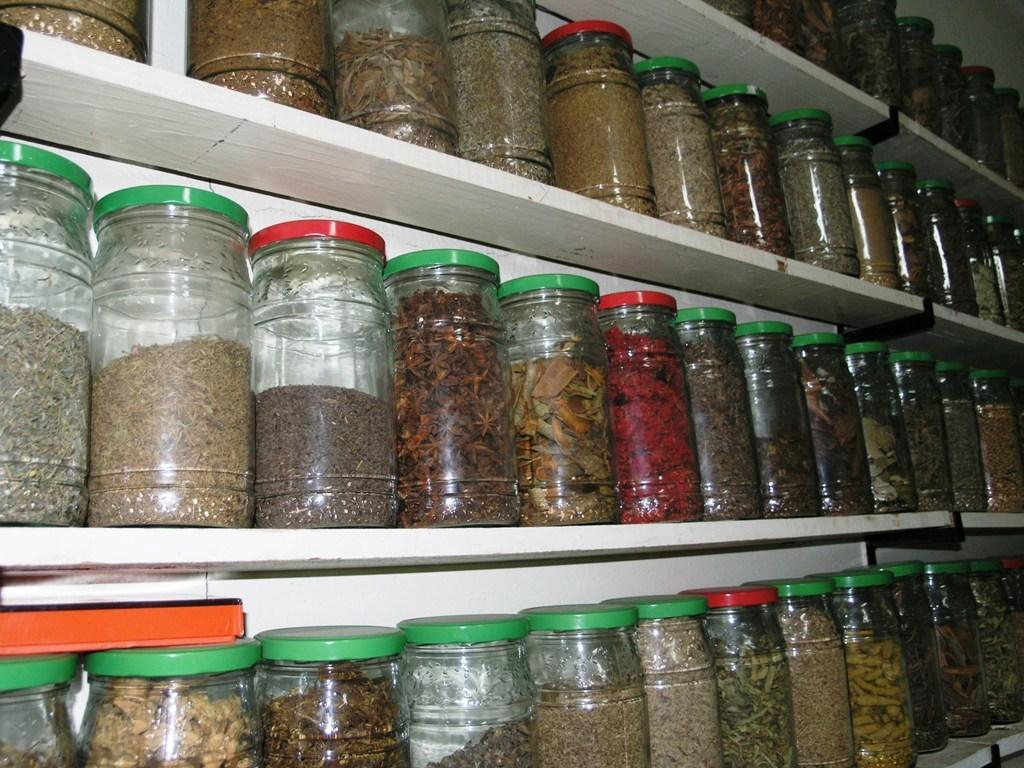What objects are visible in the image? There are jars in the image. Where are the jars located? The jars are on a shelf. What is inside the jars? The jars contain food items. What colors are the caps of the jars? The jars have red and green color caps. What type of cloth is used to cover the jars during their journey? There is no journey mentioned in the image, and no cloth is visible covering the jars. 